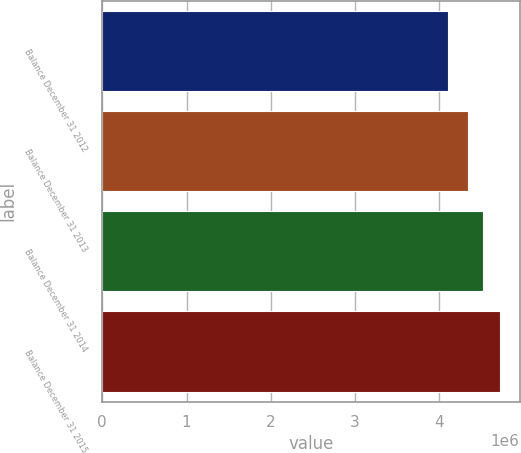Convert chart. <chart><loc_0><loc_0><loc_500><loc_500><bar_chart><fcel>Balance December 31 2012<fcel>Balance December 31 2013<fcel>Balance December 31 2014<fcel>Balance December 31 2015<nl><fcel>4.10229e+06<fcel>4.34046e+06<fcel>4.5191e+06<fcel>4.71946e+06<nl></chart> 